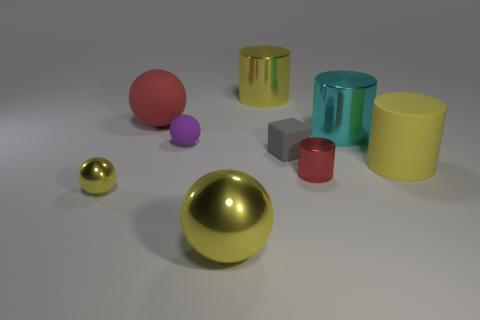There is a large metallic cylinder left of the gray object; what number of yellow objects are in front of it?
Ensure brevity in your answer.  3. Are there any other tiny things of the same shape as the small yellow metallic thing?
Offer a terse response. Yes. There is a yellow cylinder to the left of the red shiny cylinder; is its size the same as the gray rubber object that is in front of the large cyan thing?
Offer a terse response. No. What is the shape of the red object that is to the left of the tiny matte ball that is to the right of the tiny yellow object?
Keep it short and to the point. Sphere. How many purple matte balls have the same size as the gray block?
Provide a succinct answer. 1. Are there any tiny blue balls?
Give a very brief answer. No. Is there anything else of the same color as the tiny metallic ball?
Give a very brief answer. Yes. The big red object that is made of the same material as the small gray object is what shape?
Make the answer very short. Sphere. There is a large matte cylinder in front of the small purple thing on the left side of the big cylinder left of the small cylinder; what is its color?
Offer a terse response. Yellow. Are there the same number of tiny shiny things that are right of the big yellow metal cylinder and red matte cylinders?
Give a very brief answer. No. 